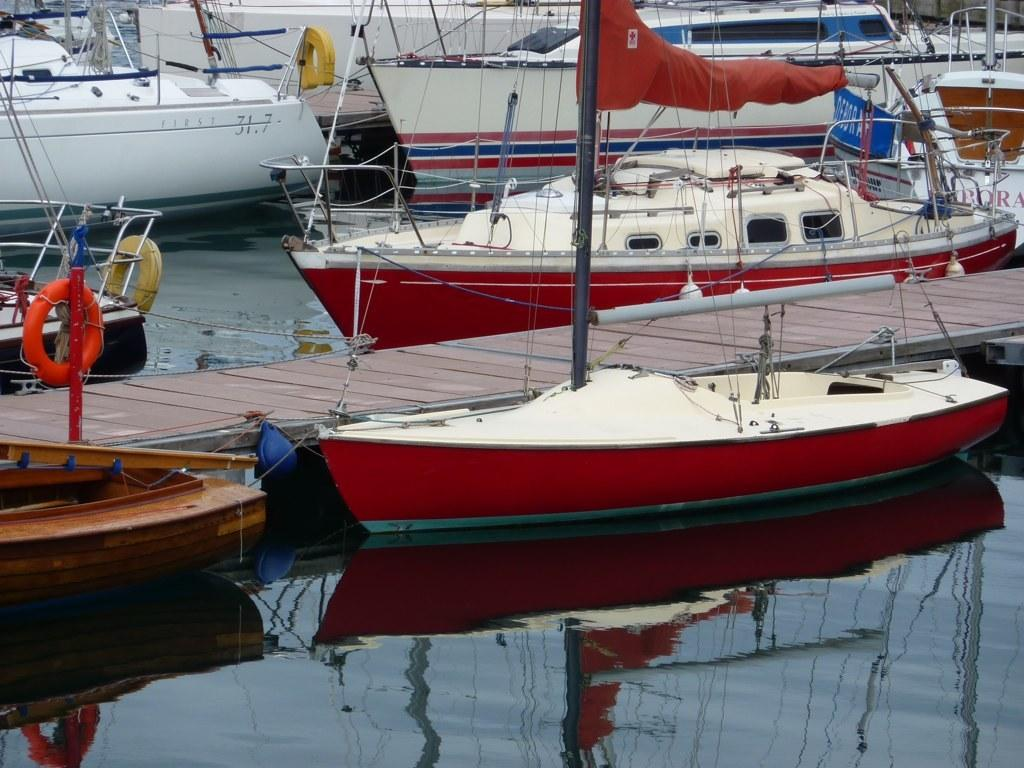What type of vehicles are in the image? There are boats in the image. Where are the boats located? The boats are on water in the image. What structure can be seen in the image? There is a bridge in the image. What feature is present on the bridge? The bridge has poles. What type of rhythm can be heard coming from the boats in the image? There is no sound or rhythm present in the image; it is a still image of boats on water. 